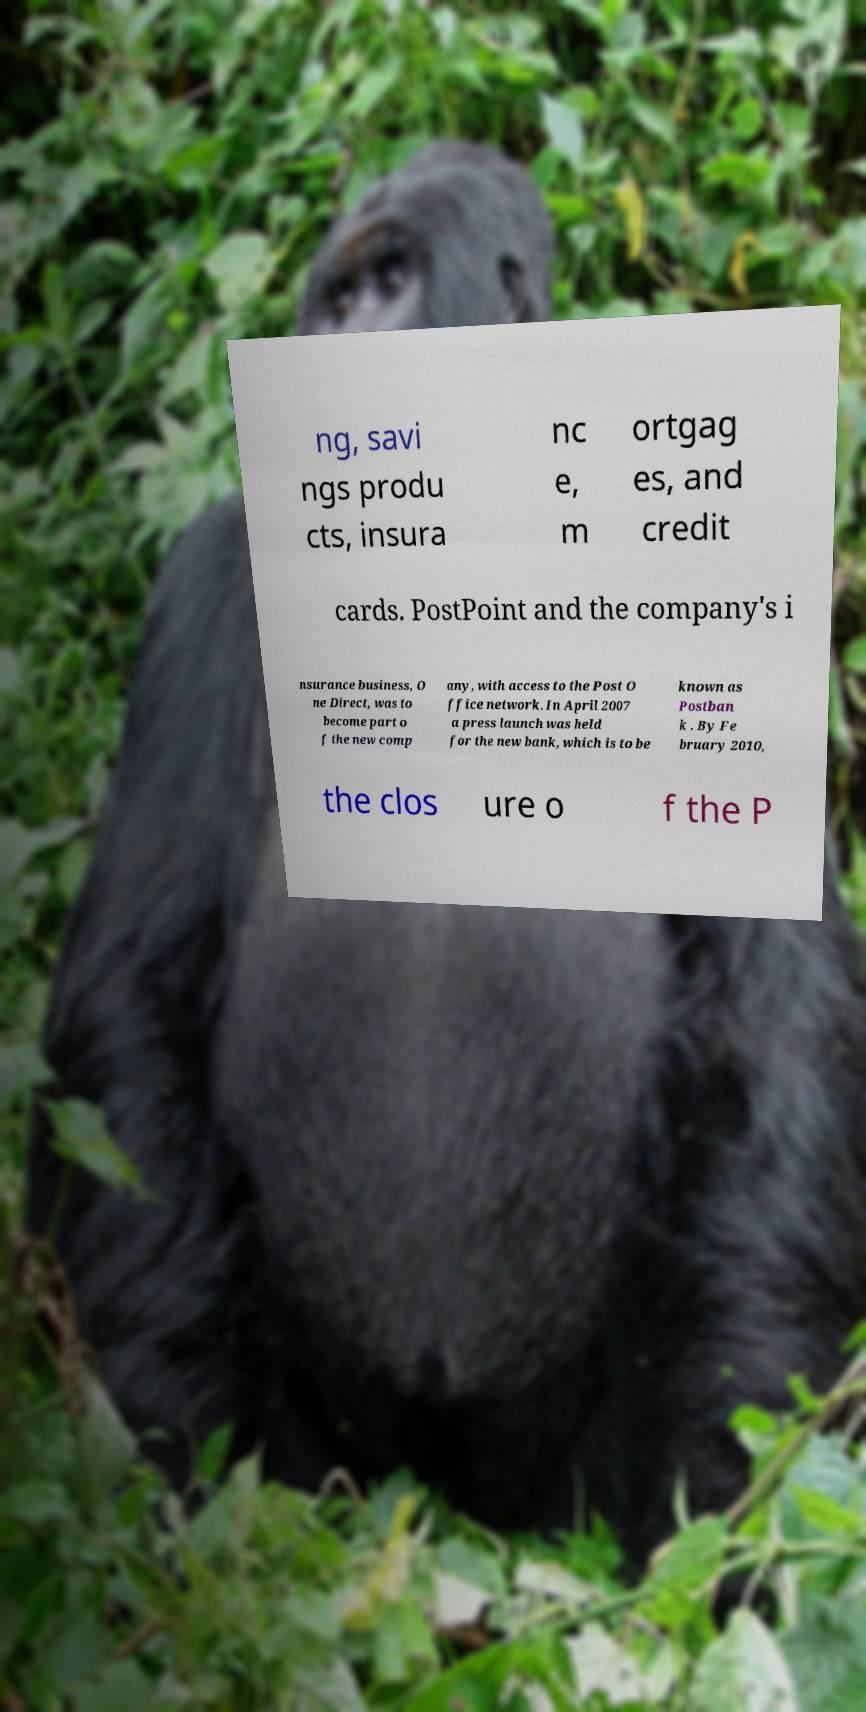Can you read and provide the text displayed in the image?This photo seems to have some interesting text. Can you extract and type it out for me? ng, savi ngs produ cts, insura nc e, m ortgag es, and credit cards. PostPoint and the company's i nsurance business, O ne Direct, was to become part o f the new comp any, with access to the Post O ffice network. In April 2007 a press launch was held for the new bank, which is to be known as Postban k . By Fe bruary 2010, the clos ure o f the P 